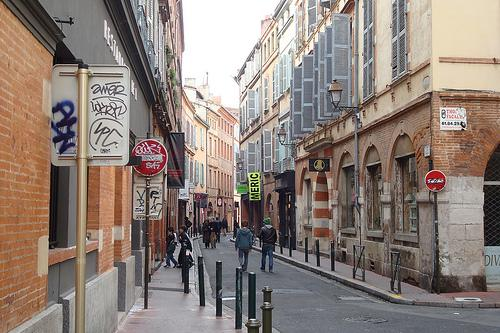Describe the appearance of the poles mentioned in the image description. The poles are green and line the sidewalk. Describe any banners or signs present in the image. There is a yellow banner that says "meric" and several round red caution signs. What is the main activity taking place on the pavement in the image? Two males are walking on the pavement and people are standing on the sidewalk. Mention an object on a person's head and its color in the image. There is a green hat on a person's head. Identify the color and shape of the sign mentioned in the image description. The sign is round and red. Provide a short description of the buildings in the image. The buildings are made of brick with arched windows and some windows are open. Provide a brief description of the graffiti in the image. The graffiti is on a sign and features black writing on a yellow background. List three elements that can be found on the sidewalk in the image. Green posts, black metal posts, and two metal gates can be found on the sidewalk. What is the general state of objects in the image, according to the description, about the road, light, shutters, and jacket? The road is black, the light is off, the shutters are open, and the jacket is either black or blue. List three activities happening in the image involving people. Two people are walking on the road, people are standing on the sidewalk, and men are standing in the street. 